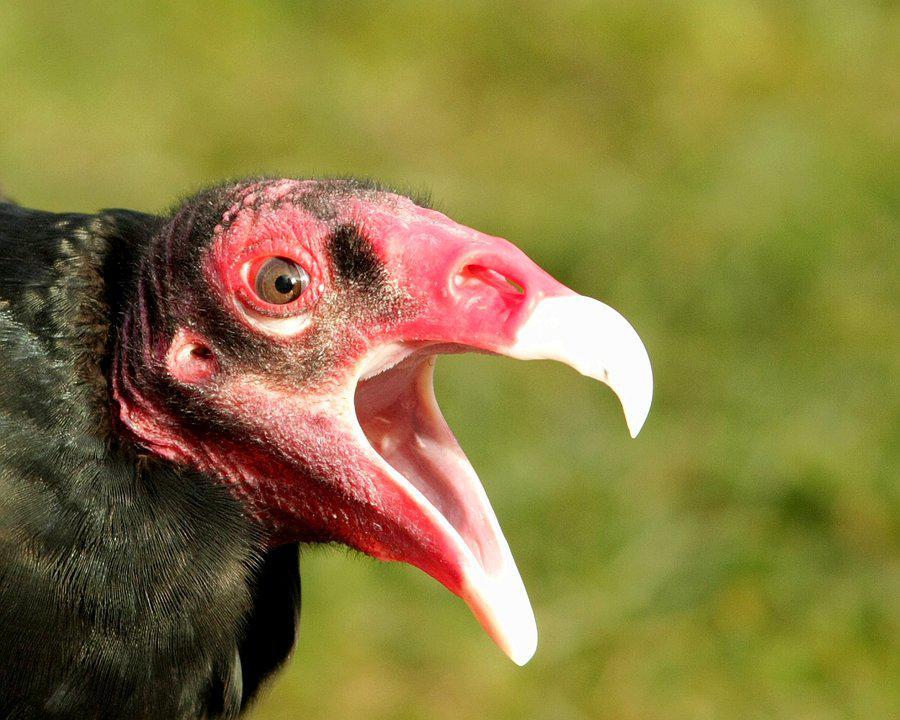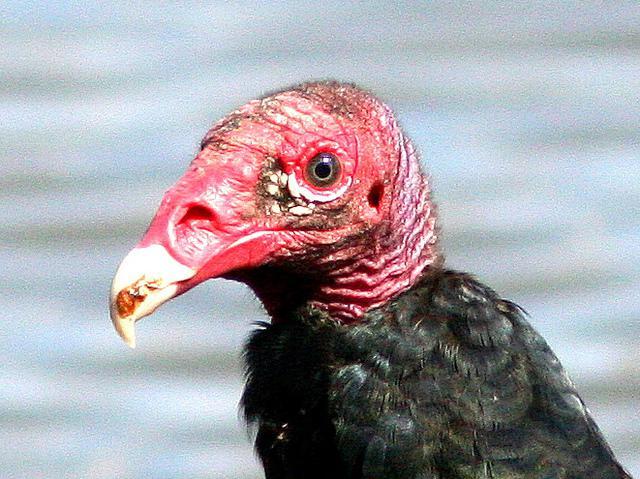The first image is the image on the left, the second image is the image on the right. Analyze the images presented: Is the assertion "Left and right images show heads of vultures facing opposite left-or-right directions." valid? Answer yes or no. Yes. The first image is the image on the left, the second image is the image on the right. For the images shown, is this caption "The bird in the left image is looking towards the left." true? Answer yes or no. No. 